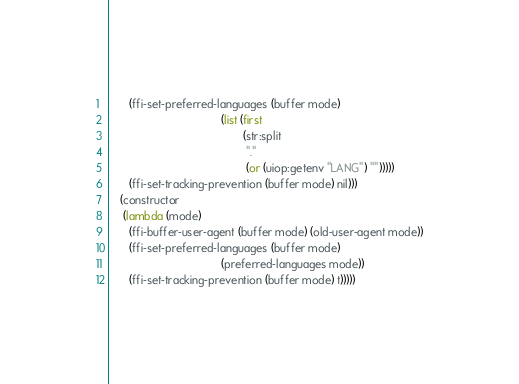<code> <loc_0><loc_0><loc_500><loc_500><_Lisp_>      (ffi-set-preferred-languages (buffer mode)
                                   (list (first
                                          (str:split
                                           "."
                                           (or (uiop:getenv "LANG") "")))))
      (ffi-set-tracking-prevention (buffer mode) nil)))
   (constructor
    (lambda (mode)
      (ffi-buffer-user-agent (buffer mode) (old-user-agent mode))
      (ffi-set-preferred-languages (buffer mode)
                                   (preferred-languages mode))
      (ffi-set-tracking-prevention (buffer mode) t)))))
</code> 